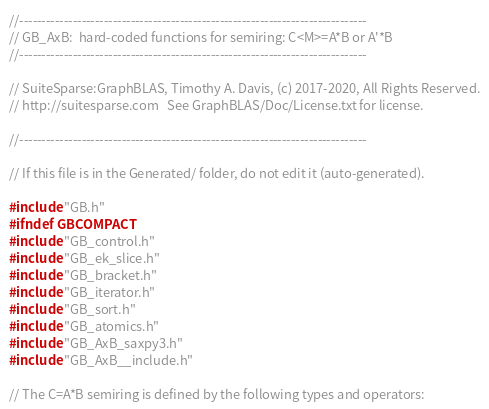<code> <loc_0><loc_0><loc_500><loc_500><_C_>//------------------------------------------------------------------------------
// GB_AxB:  hard-coded functions for semiring: C<M>=A*B or A'*B
//------------------------------------------------------------------------------

// SuiteSparse:GraphBLAS, Timothy A. Davis, (c) 2017-2020, All Rights Reserved.
// http://suitesparse.com   See GraphBLAS/Doc/License.txt for license.

//------------------------------------------------------------------------------

// If this file is in the Generated/ folder, do not edit it (auto-generated).

#include "GB.h"
#ifndef GBCOMPACT
#include "GB_control.h"
#include "GB_ek_slice.h"
#include "GB_bracket.h"
#include "GB_iterator.h"
#include "GB_sort.h"
#include "GB_atomics.h"
#include "GB_AxB_saxpy3.h"
#include "GB_AxB__include.h"

// The C=A*B semiring is defined by the following types and operators:
</code> 